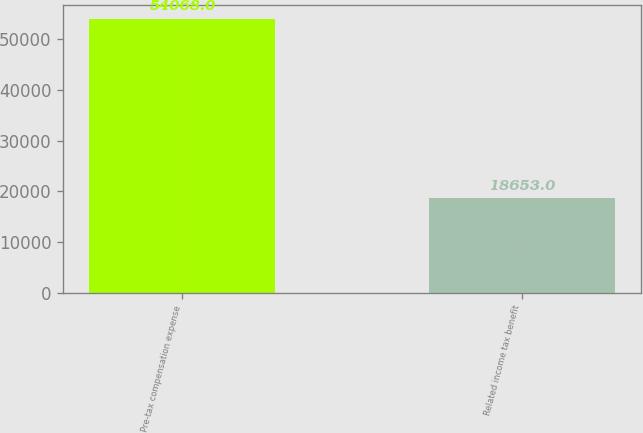<chart> <loc_0><loc_0><loc_500><loc_500><bar_chart><fcel>Pre-tax compensation expense<fcel>Related income tax benefit<nl><fcel>54068<fcel>18653<nl></chart> 